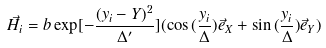<formula> <loc_0><loc_0><loc_500><loc_500>\vec { H } _ { i } = b \exp [ { - \frac { ( y _ { i } - Y ) ^ { 2 } } { \Delta ^ { \prime } } } ] ( \cos { ( \frac { y _ { i } } { \Delta } ) } \vec { e } _ { X } + \sin { ( \frac { y _ { i } } { \Delta } ) } \vec { e } _ { Y } )</formula> 